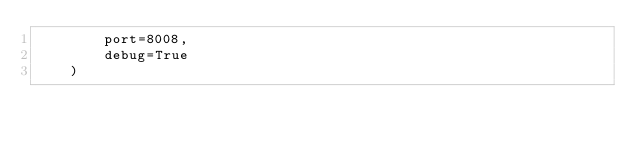Convert code to text. <code><loc_0><loc_0><loc_500><loc_500><_Python_>        port=8008,
        debug=True
    )
</code> 